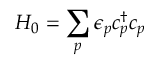<formula> <loc_0><loc_0><loc_500><loc_500>H _ { 0 } = \sum _ { p } \epsilon _ { p } c _ { p } ^ { \dagger } c _ { p }</formula> 